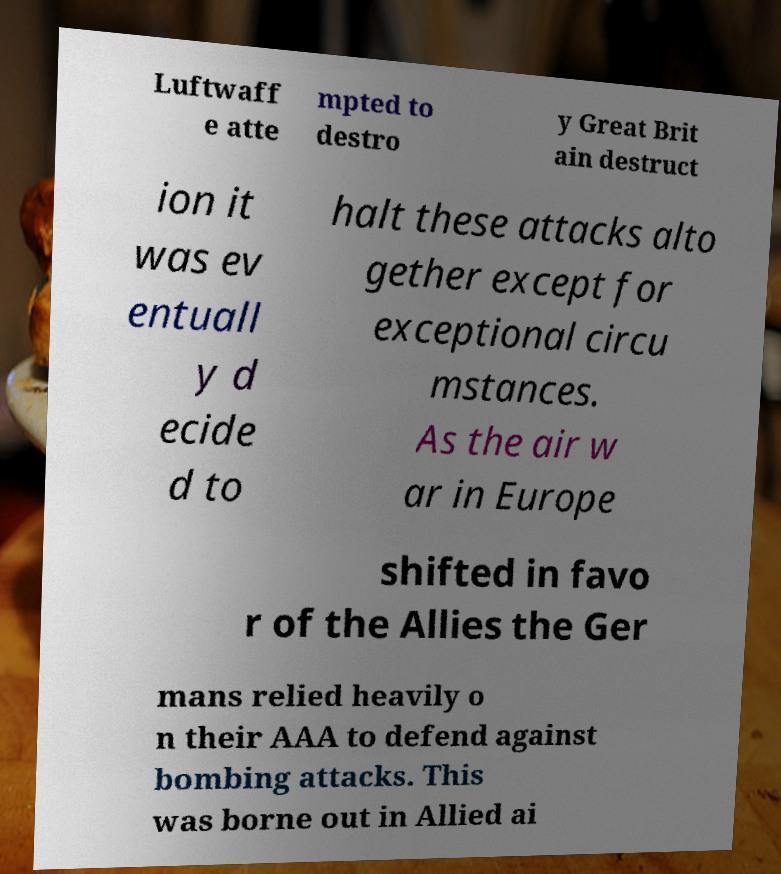Could you extract and type out the text from this image? Luftwaff e atte mpted to destro y Great Brit ain destruct ion it was ev entuall y d ecide d to halt these attacks alto gether except for exceptional circu mstances. As the air w ar in Europe shifted in favo r of the Allies the Ger mans relied heavily o n their AAA to defend against bombing attacks. This was borne out in Allied ai 